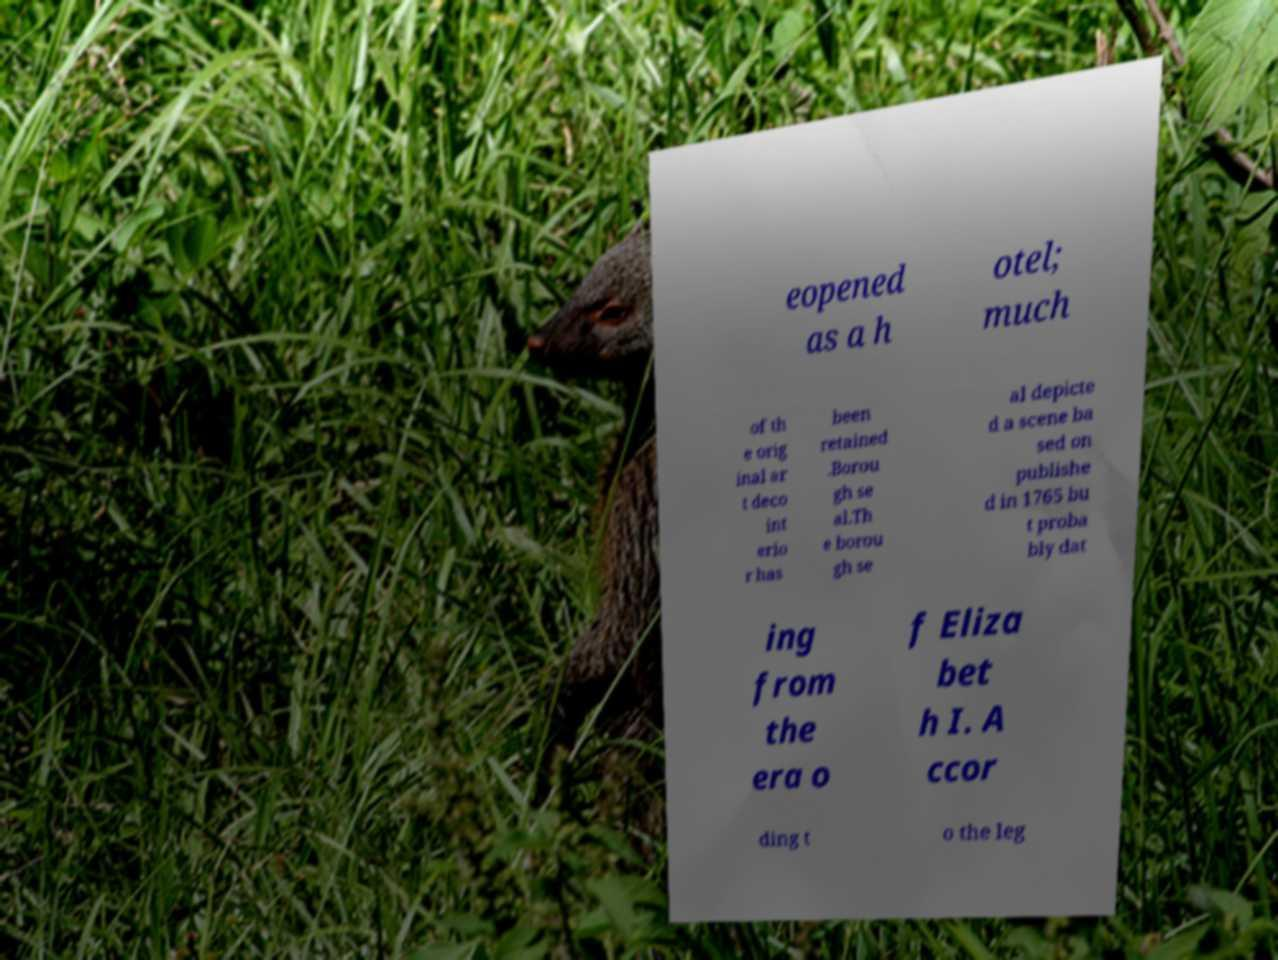I need the written content from this picture converted into text. Can you do that? eopened as a h otel; much of th e orig inal ar t deco int erio r has been retained .Borou gh se al.Th e borou gh se al depicte d a scene ba sed on publishe d in 1765 bu t proba bly dat ing from the era o f Eliza bet h I. A ccor ding t o the leg 